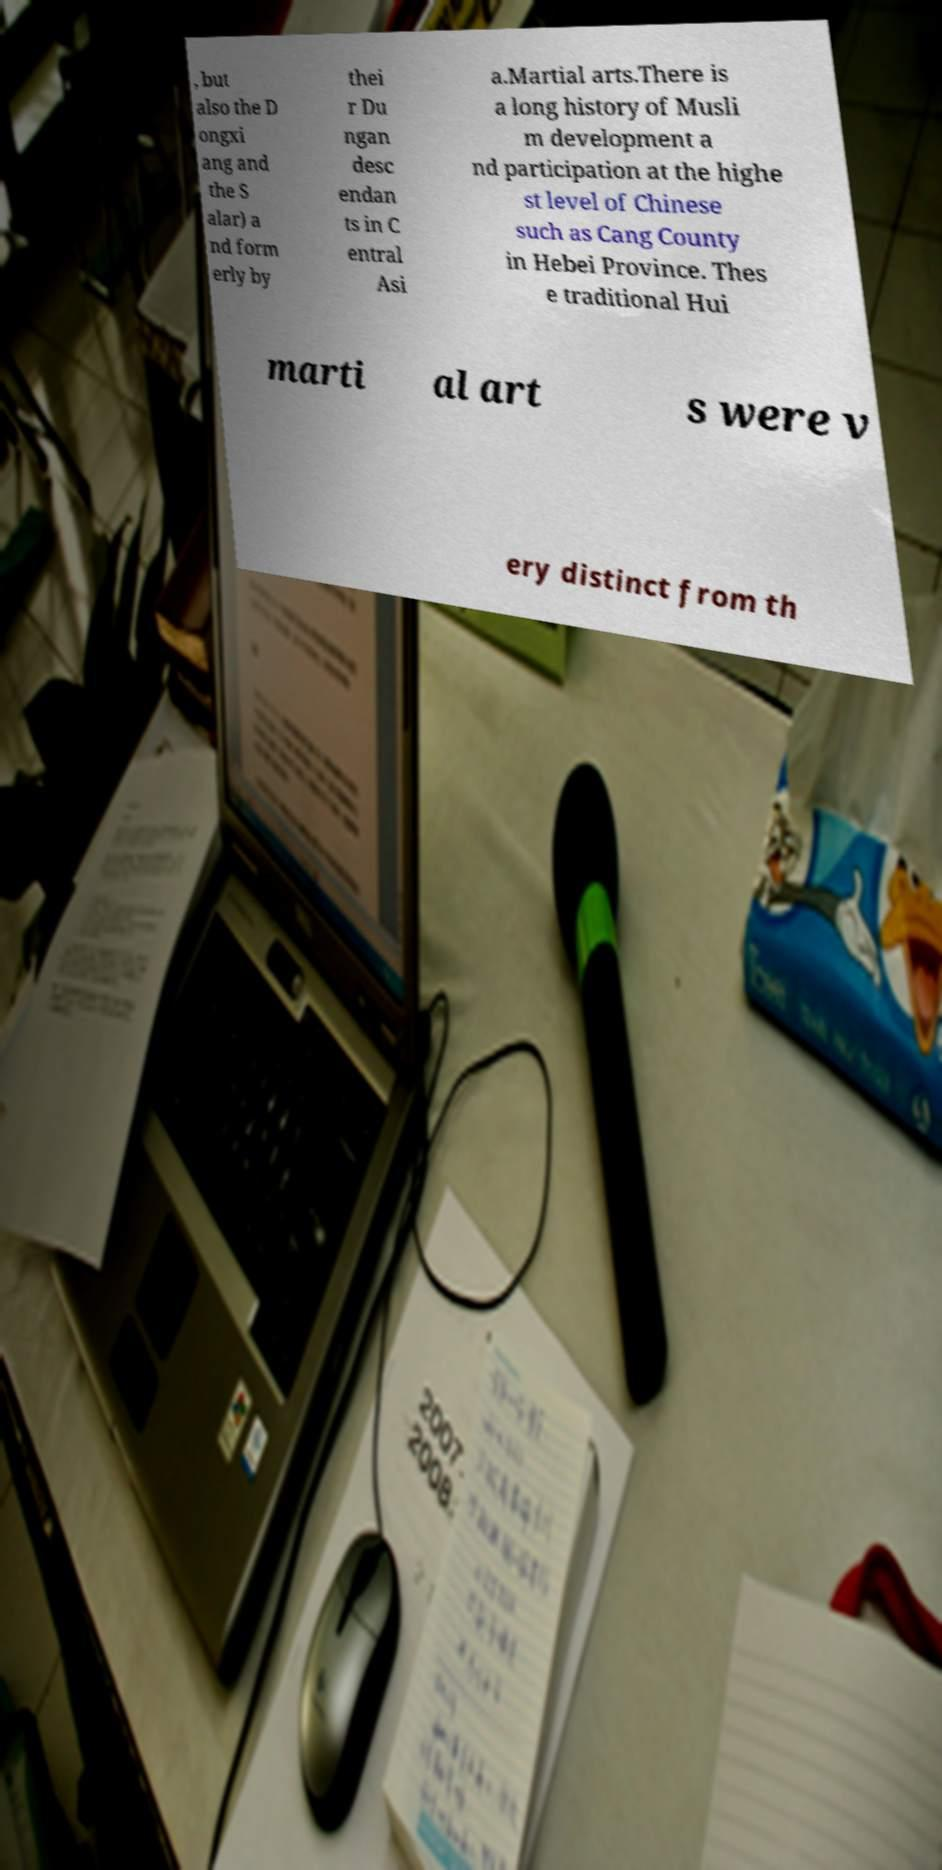For documentation purposes, I need the text within this image transcribed. Could you provide that? , but also the D ongxi ang and the S alar) a nd form erly by thei r Du ngan desc endan ts in C entral Asi a.Martial arts.There is a long history of Musli m development a nd participation at the highe st level of Chinese such as Cang County in Hebei Province. Thes e traditional Hui marti al art s were v ery distinct from th 